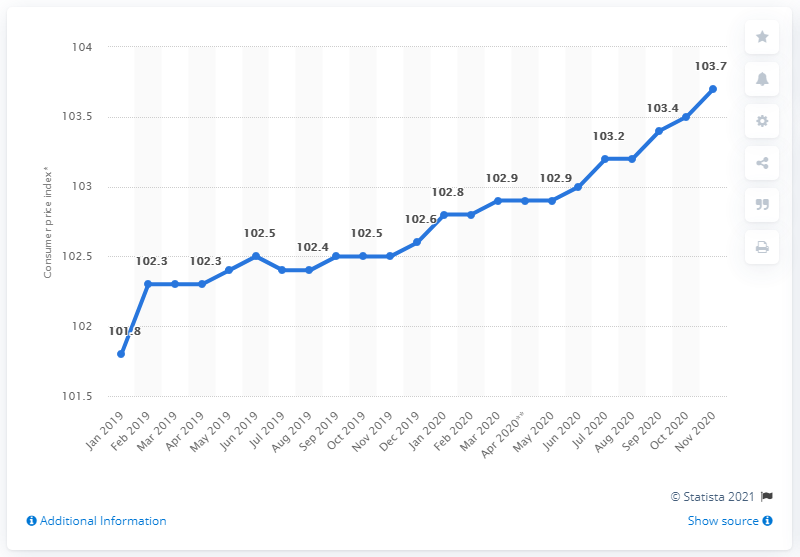List a handful of essential elements in this visual. In November 2020, the monthly Consumer Price Index (CPI) for vending machines in Italy was 103.7. 